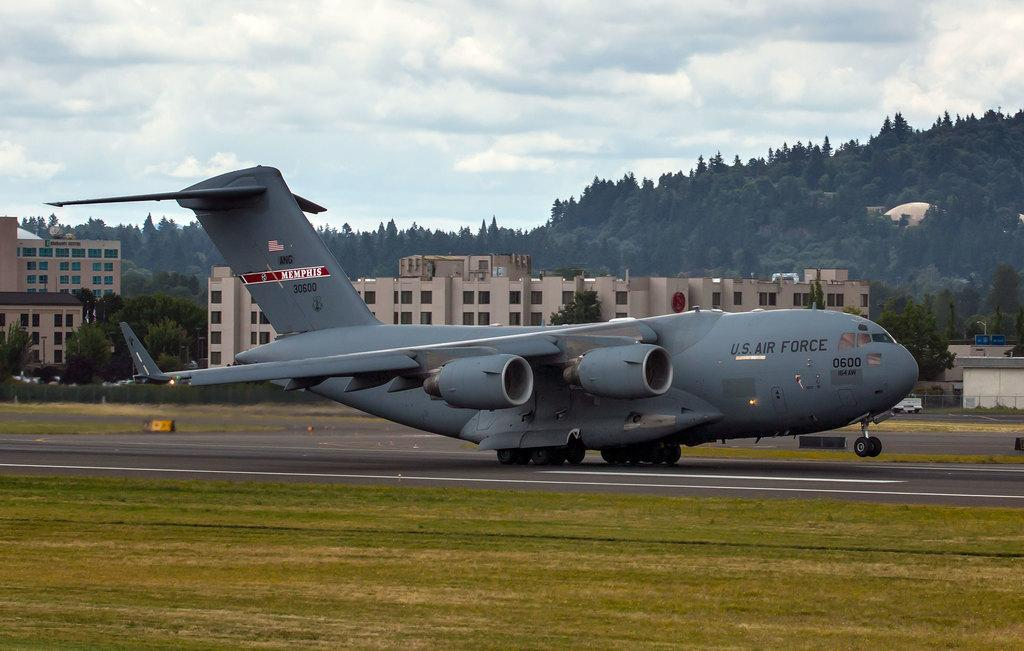<image>
Present a compact description of the photo's key features. a plane that has air force written on it 